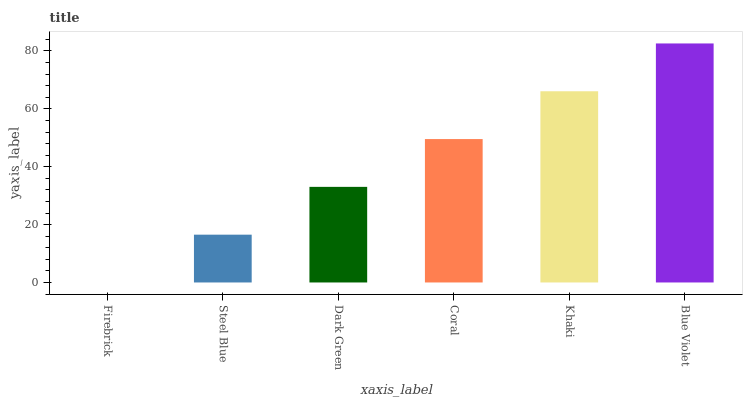Is Firebrick the minimum?
Answer yes or no. Yes. Is Blue Violet the maximum?
Answer yes or no. Yes. Is Steel Blue the minimum?
Answer yes or no. No. Is Steel Blue the maximum?
Answer yes or no. No. Is Steel Blue greater than Firebrick?
Answer yes or no. Yes. Is Firebrick less than Steel Blue?
Answer yes or no. Yes. Is Firebrick greater than Steel Blue?
Answer yes or no. No. Is Steel Blue less than Firebrick?
Answer yes or no. No. Is Coral the high median?
Answer yes or no. Yes. Is Dark Green the low median?
Answer yes or no. Yes. Is Blue Violet the high median?
Answer yes or no. No. Is Steel Blue the low median?
Answer yes or no. No. 